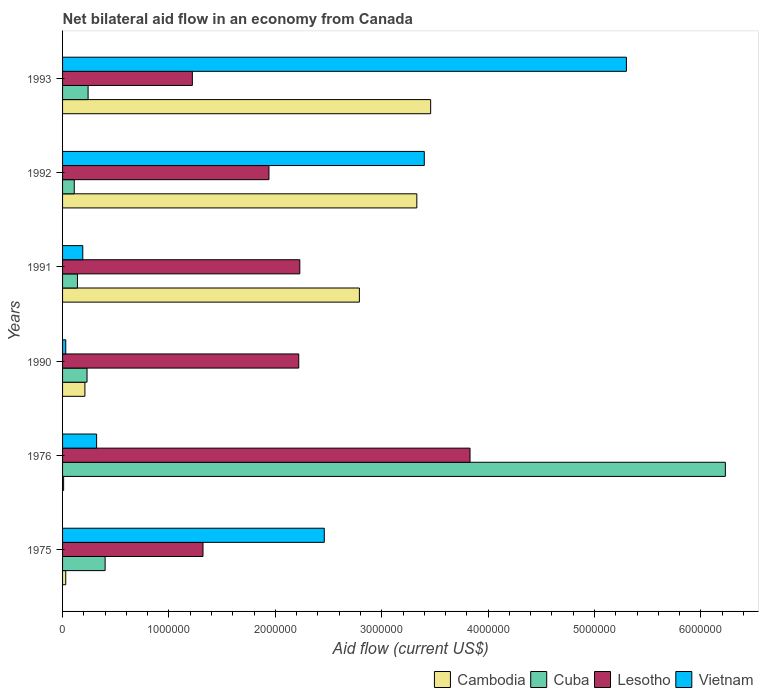How many different coloured bars are there?
Your answer should be very brief. 4. Are the number of bars on each tick of the Y-axis equal?
Provide a short and direct response. Yes. How many bars are there on the 3rd tick from the top?
Provide a succinct answer. 4. What is the label of the 2nd group of bars from the top?
Provide a succinct answer. 1992. What is the net bilateral aid flow in Lesotho in 1993?
Your response must be concise. 1.22e+06. Across all years, what is the maximum net bilateral aid flow in Lesotho?
Make the answer very short. 3.83e+06. What is the total net bilateral aid flow in Cambodia in the graph?
Your response must be concise. 9.83e+06. What is the difference between the net bilateral aid flow in Cuba in 1992 and the net bilateral aid flow in Lesotho in 1976?
Your answer should be very brief. -3.72e+06. What is the average net bilateral aid flow in Cuba per year?
Give a very brief answer. 1.22e+06. In the year 1991, what is the difference between the net bilateral aid flow in Cuba and net bilateral aid flow in Lesotho?
Provide a succinct answer. -2.09e+06. In how many years, is the net bilateral aid flow in Lesotho greater than 5800000 US$?
Make the answer very short. 0. What is the ratio of the net bilateral aid flow in Cuba in 1975 to that in 1976?
Give a very brief answer. 0.06. Is the net bilateral aid flow in Lesotho in 1991 less than that in 1992?
Your answer should be very brief. No. What is the difference between the highest and the second highest net bilateral aid flow in Lesotho?
Offer a terse response. 1.60e+06. What is the difference between the highest and the lowest net bilateral aid flow in Cuba?
Your response must be concise. 6.12e+06. In how many years, is the net bilateral aid flow in Cuba greater than the average net bilateral aid flow in Cuba taken over all years?
Provide a short and direct response. 1. What does the 4th bar from the top in 1975 represents?
Provide a succinct answer. Cambodia. What does the 2nd bar from the bottom in 1991 represents?
Your answer should be compact. Cuba. Is it the case that in every year, the sum of the net bilateral aid flow in Cuba and net bilateral aid flow in Cambodia is greater than the net bilateral aid flow in Lesotho?
Ensure brevity in your answer.  No. Are the values on the major ticks of X-axis written in scientific E-notation?
Your response must be concise. No. Does the graph contain grids?
Offer a very short reply. No. How are the legend labels stacked?
Your answer should be compact. Horizontal. What is the title of the graph?
Ensure brevity in your answer.  Net bilateral aid flow in an economy from Canada. What is the Aid flow (current US$) of Cuba in 1975?
Your answer should be very brief. 4.00e+05. What is the Aid flow (current US$) in Lesotho in 1975?
Offer a terse response. 1.32e+06. What is the Aid flow (current US$) in Vietnam in 1975?
Keep it short and to the point. 2.46e+06. What is the Aid flow (current US$) of Cambodia in 1976?
Your response must be concise. 10000. What is the Aid flow (current US$) in Cuba in 1976?
Offer a very short reply. 6.23e+06. What is the Aid flow (current US$) of Lesotho in 1976?
Give a very brief answer. 3.83e+06. What is the Aid flow (current US$) in Cambodia in 1990?
Keep it short and to the point. 2.10e+05. What is the Aid flow (current US$) in Cuba in 1990?
Your answer should be very brief. 2.30e+05. What is the Aid flow (current US$) of Lesotho in 1990?
Ensure brevity in your answer.  2.22e+06. What is the Aid flow (current US$) of Cambodia in 1991?
Keep it short and to the point. 2.79e+06. What is the Aid flow (current US$) of Lesotho in 1991?
Offer a very short reply. 2.23e+06. What is the Aid flow (current US$) of Vietnam in 1991?
Provide a short and direct response. 1.90e+05. What is the Aid flow (current US$) in Cambodia in 1992?
Your response must be concise. 3.33e+06. What is the Aid flow (current US$) in Lesotho in 1992?
Your answer should be very brief. 1.94e+06. What is the Aid flow (current US$) of Vietnam in 1992?
Give a very brief answer. 3.40e+06. What is the Aid flow (current US$) in Cambodia in 1993?
Provide a short and direct response. 3.46e+06. What is the Aid flow (current US$) in Cuba in 1993?
Give a very brief answer. 2.40e+05. What is the Aid flow (current US$) in Lesotho in 1993?
Provide a succinct answer. 1.22e+06. What is the Aid flow (current US$) of Vietnam in 1993?
Your response must be concise. 5.30e+06. Across all years, what is the maximum Aid flow (current US$) of Cambodia?
Offer a terse response. 3.46e+06. Across all years, what is the maximum Aid flow (current US$) in Cuba?
Give a very brief answer. 6.23e+06. Across all years, what is the maximum Aid flow (current US$) of Lesotho?
Your answer should be very brief. 3.83e+06. Across all years, what is the maximum Aid flow (current US$) in Vietnam?
Ensure brevity in your answer.  5.30e+06. Across all years, what is the minimum Aid flow (current US$) in Cuba?
Provide a succinct answer. 1.10e+05. Across all years, what is the minimum Aid flow (current US$) of Lesotho?
Provide a succinct answer. 1.22e+06. Across all years, what is the minimum Aid flow (current US$) in Vietnam?
Make the answer very short. 3.00e+04. What is the total Aid flow (current US$) of Cambodia in the graph?
Offer a very short reply. 9.83e+06. What is the total Aid flow (current US$) of Cuba in the graph?
Offer a very short reply. 7.35e+06. What is the total Aid flow (current US$) of Lesotho in the graph?
Keep it short and to the point. 1.28e+07. What is the total Aid flow (current US$) in Vietnam in the graph?
Make the answer very short. 1.17e+07. What is the difference between the Aid flow (current US$) in Cuba in 1975 and that in 1976?
Your answer should be compact. -5.83e+06. What is the difference between the Aid flow (current US$) of Lesotho in 1975 and that in 1976?
Your response must be concise. -2.51e+06. What is the difference between the Aid flow (current US$) of Vietnam in 1975 and that in 1976?
Give a very brief answer. 2.14e+06. What is the difference between the Aid flow (current US$) of Cuba in 1975 and that in 1990?
Keep it short and to the point. 1.70e+05. What is the difference between the Aid flow (current US$) of Lesotho in 1975 and that in 1990?
Make the answer very short. -9.00e+05. What is the difference between the Aid flow (current US$) in Vietnam in 1975 and that in 1990?
Make the answer very short. 2.43e+06. What is the difference between the Aid flow (current US$) of Cambodia in 1975 and that in 1991?
Your answer should be compact. -2.76e+06. What is the difference between the Aid flow (current US$) of Cuba in 1975 and that in 1991?
Your answer should be very brief. 2.60e+05. What is the difference between the Aid flow (current US$) of Lesotho in 1975 and that in 1991?
Make the answer very short. -9.10e+05. What is the difference between the Aid flow (current US$) in Vietnam in 1975 and that in 1991?
Your answer should be compact. 2.27e+06. What is the difference between the Aid flow (current US$) in Cambodia in 1975 and that in 1992?
Keep it short and to the point. -3.30e+06. What is the difference between the Aid flow (current US$) of Cuba in 1975 and that in 1992?
Your response must be concise. 2.90e+05. What is the difference between the Aid flow (current US$) in Lesotho in 1975 and that in 1992?
Provide a succinct answer. -6.20e+05. What is the difference between the Aid flow (current US$) in Vietnam in 1975 and that in 1992?
Offer a very short reply. -9.40e+05. What is the difference between the Aid flow (current US$) in Cambodia in 1975 and that in 1993?
Offer a terse response. -3.43e+06. What is the difference between the Aid flow (current US$) in Lesotho in 1975 and that in 1993?
Ensure brevity in your answer.  1.00e+05. What is the difference between the Aid flow (current US$) in Vietnam in 1975 and that in 1993?
Ensure brevity in your answer.  -2.84e+06. What is the difference between the Aid flow (current US$) in Cambodia in 1976 and that in 1990?
Give a very brief answer. -2.00e+05. What is the difference between the Aid flow (current US$) of Cuba in 1976 and that in 1990?
Provide a succinct answer. 6.00e+06. What is the difference between the Aid flow (current US$) in Lesotho in 1976 and that in 1990?
Make the answer very short. 1.61e+06. What is the difference between the Aid flow (current US$) in Cambodia in 1976 and that in 1991?
Make the answer very short. -2.78e+06. What is the difference between the Aid flow (current US$) in Cuba in 1976 and that in 1991?
Your answer should be very brief. 6.09e+06. What is the difference between the Aid flow (current US$) of Lesotho in 1976 and that in 1991?
Offer a very short reply. 1.60e+06. What is the difference between the Aid flow (current US$) in Vietnam in 1976 and that in 1991?
Provide a short and direct response. 1.30e+05. What is the difference between the Aid flow (current US$) in Cambodia in 1976 and that in 1992?
Your answer should be very brief. -3.32e+06. What is the difference between the Aid flow (current US$) of Cuba in 1976 and that in 1992?
Ensure brevity in your answer.  6.12e+06. What is the difference between the Aid flow (current US$) of Lesotho in 1976 and that in 1992?
Provide a short and direct response. 1.89e+06. What is the difference between the Aid flow (current US$) in Vietnam in 1976 and that in 1992?
Offer a very short reply. -3.08e+06. What is the difference between the Aid flow (current US$) in Cambodia in 1976 and that in 1993?
Give a very brief answer. -3.45e+06. What is the difference between the Aid flow (current US$) in Cuba in 1976 and that in 1993?
Keep it short and to the point. 5.99e+06. What is the difference between the Aid flow (current US$) of Lesotho in 1976 and that in 1993?
Offer a very short reply. 2.61e+06. What is the difference between the Aid flow (current US$) of Vietnam in 1976 and that in 1993?
Ensure brevity in your answer.  -4.98e+06. What is the difference between the Aid flow (current US$) in Cambodia in 1990 and that in 1991?
Ensure brevity in your answer.  -2.58e+06. What is the difference between the Aid flow (current US$) in Cuba in 1990 and that in 1991?
Make the answer very short. 9.00e+04. What is the difference between the Aid flow (current US$) of Lesotho in 1990 and that in 1991?
Make the answer very short. -10000. What is the difference between the Aid flow (current US$) in Cambodia in 1990 and that in 1992?
Provide a short and direct response. -3.12e+06. What is the difference between the Aid flow (current US$) in Cuba in 1990 and that in 1992?
Ensure brevity in your answer.  1.20e+05. What is the difference between the Aid flow (current US$) of Lesotho in 1990 and that in 1992?
Make the answer very short. 2.80e+05. What is the difference between the Aid flow (current US$) in Vietnam in 1990 and that in 1992?
Offer a terse response. -3.37e+06. What is the difference between the Aid flow (current US$) in Cambodia in 1990 and that in 1993?
Ensure brevity in your answer.  -3.25e+06. What is the difference between the Aid flow (current US$) of Cuba in 1990 and that in 1993?
Provide a succinct answer. -10000. What is the difference between the Aid flow (current US$) in Vietnam in 1990 and that in 1993?
Provide a succinct answer. -5.27e+06. What is the difference between the Aid flow (current US$) in Cambodia in 1991 and that in 1992?
Make the answer very short. -5.40e+05. What is the difference between the Aid flow (current US$) in Cuba in 1991 and that in 1992?
Your answer should be very brief. 3.00e+04. What is the difference between the Aid flow (current US$) of Vietnam in 1991 and that in 1992?
Your answer should be compact. -3.21e+06. What is the difference between the Aid flow (current US$) of Cambodia in 1991 and that in 1993?
Make the answer very short. -6.70e+05. What is the difference between the Aid flow (current US$) in Lesotho in 1991 and that in 1993?
Your answer should be very brief. 1.01e+06. What is the difference between the Aid flow (current US$) in Vietnam in 1991 and that in 1993?
Your answer should be very brief. -5.11e+06. What is the difference between the Aid flow (current US$) in Cambodia in 1992 and that in 1993?
Your response must be concise. -1.30e+05. What is the difference between the Aid flow (current US$) in Cuba in 1992 and that in 1993?
Your answer should be compact. -1.30e+05. What is the difference between the Aid flow (current US$) in Lesotho in 1992 and that in 1993?
Provide a short and direct response. 7.20e+05. What is the difference between the Aid flow (current US$) in Vietnam in 1992 and that in 1993?
Offer a very short reply. -1.90e+06. What is the difference between the Aid flow (current US$) in Cambodia in 1975 and the Aid flow (current US$) in Cuba in 1976?
Ensure brevity in your answer.  -6.20e+06. What is the difference between the Aid flow (current US$) in Cambodia in 1975 and the Aid flow (current US$) in Lesotho in 1976?
Offer a terse response. -3.80e+06. What is the difference between the Aid flow (current US$) in Cambodia in 1975 and the Aid flow (current US$) in Vietnam in 1976?
Your response must be concise. -2.90e+05. What is the difference between the Aid flow (current US$) of Cuba in 1975 and the Aid flow (current US$) of Lesotho in 1976?
Provide a succinct answer. -3.43e+06. What is the difference between the Aid flow (current US$) in Cambodia in 1975 and the Aid flow (current US$) in Lesotho in 1990?
Your response must be concise. -2.19e+06. What is the difference between the Aid flow (current US$) in Cambodia in 1975 and the Aid flow (current US$) in Vietnam in 1990?
Provide a short and direct response. 0. What is the difference between the Aid flow (current US$) in Cuba in 1975 and the Aid flow (current US$) in Lesotho in 1990?
Your answer should be compact. -1.82e+06. What is the difference between the Aid flow (current US$) of Cuba in 1975 and the Aid flow (current US$) of Vietnam in 1990?
Make the answer very short. 3.70e+05. What is the difference between the Aid flow (current US$) of Lesotho in 1975 and the Aid flow (current US$) of Vietnam in 1990?
Ensure brevity in your answer.  1.29e+06. What is the difference between the Aid flow (current US$) in Cambodia in 1975 and the Aid flow (current US$) in Lesotho in 1991?
Provide a succinct answer. -2.20e+06. What is the difference between the Aid flow (current US$) in Cuba in 1975 and the Aid flow (current US$) in Lesotho in 1991?
Keep it short and to the point. -1.83e+06. What is the difference between the Aid flow (current US$) of Cuba in 1975 and the Aid flow (current US$) of Vietnam in 1991?
Provide a short and direct response. 2.10e+05. What is the difference between the Aid flow (current US$) in Lesotho in 1975 and the Aid flow (current US$) in Vietnam in 1991?
Give a very brief answer. 1.13e+06. What is the difference between the Aid flow (current US$) of Cambodia in 1975 and the Aid flow (current US$) of Lesotho in 1992?
Keep it short and to the point. -1.91e+06. What is the difference between the Aid flow (current US$) of Cambodia in 1975 and the Aid flow (current US$) of Vietnam in 1992?
Offer a terse response. -3.37e+06. What is the difference between the Aid flow (current US$) in Cuba in 1975 and the Aid flow (current US$) in Lesotho in 1992?
Ensure brevity in your answer.  -1.54e+06. What is the difference between the Aid flow (current US$) in Cuba in 1975 and the Aid flow (current US$) in Vietnam in 1992?
Your response must be concise. -3.00e+06. What is the difference between the Aid flow (current US$) of Lesotho in 1975 and the Aid flow (current US$) of Vietnam in 1992?
Ensure brevity in your answer.  -2.08e+06. What is the difference between the Aid flow (current US$) of Cambodia in 1975 and the Aid flow (current US$) of Lesotho in 1993?
Your response must be concise. -1.19e+06. What is the difference between the Aid flow (current US$) of Cambodia in 1975 and the Aid flow (current US$) of Vietnam in 1993?
Provide a succinct answer. -5.27e+06. What is the difference between the Aid flow (current US$) in Cuba in 1975 and the Aid flow (current US$) in Lesotho in 1993?
Ensure brevity in your answer.  -8.20e+05. What is the difference between the Aid flow (current US$) in Cuba in 1975 and the Aid flow (current US$) in Vietnam in 1993?
Make the answer very short. -4.90e+06. What is the difference between the Aid flow (current US$) of Lesotho in 1975 and the Aid flow (current US$) of Vietnam in 1993?
Offer a terse response. -3.98e+06. What is the difference between the Aid flow (current US$) in Cambodia in 1976 and the Aid flow (current US$) in Cuba in 1990?
Offer a very short reply. -2.20e+05. What is the difference between the Aid flow (current US$) of Cambodia in 1976 and the Aid flow (current US$) of Lesotho in 1990?
Your response must be concise. -2.21e+06. What is the difference between the Aid flow (current US$) in Cuba in 1976 and the Aid flow (current US$) in Lesotho in 1990?
Your answer should be compact. 4.01e+06. What is the difference between the Aid flow (current US$) in Cuba in 1976 and the Aid flow (current US$) in Vietnam in 1990?
Your answer should be compact. 6.20e+06. What is the difference between the Aid flow (current US$) in Lesotho in 1976 and the Aid flow (current US$) in Vietnam in 1990?
Provide a short and direct response. 3.80e+06. What is the difference between the Aid flow (current US$) in Cambodia in 1976 and the Aid flow (current US$) in Lesotho in 1991?
Keep it short and to the point. -2.22e+06. What is the difference between the Aid flow (current US$) of Cambodia in 1976 and the Aid flow (current US$) of Vietnam in 1991?
Ensure brevity in your answer.  -1.80e+05. What is the difference between the Aid flow (current US$) of Cuba in 1976 and the Aid flow (current US$) of Lesotho in 1991?
Offer a very short reply. 4.00e+06. What is the difference between the Aid flow (current US$) of Cuba in 1976 and the Aid flow (current US$) of Vietnam in 1991?
Provide a short and direct response. 6.04e+06. What is the difference between the Aid flow (current US$) of Lesotho in 1976 and the Aid flow (current US$) of Vietnam in 1991?
Make the answer very short. 3.64e+06. What is the difference between the Aid flow (current US$) in Cambodia in 1976 and the Aid flow (current US$) in Cuba in 1992?
Make the answer very short. -1.00e+05. What is the difference between the Aid flow (current US$) of Cambodia in 1976 and the Aid flow (current US$) of Lesotho in 1992?
Give a very brief answer. -1.93e+06. What is the difference between the Aid flow (current US$) of Cambodia in 1976 and the Aid flow (current US$) of Vietnam in 1992?
Make the answer very short. -3.39e+06. What is the difference between the Aid flow (current US$) of Cuba in 1976 and the Aid flow (current US$) of Lesotho in 1992?
Give a very brief answer. 4.29e+06. What is the difference between the Aid flow (current US$) in Cuba in 1976 and the Aid flow (current US$) in Vietnam in 1992?
Offer a very short reply. 2.83e+06. What is the difference between the Aid flow (current US$) in Lesotho in 1976 and the Aid flow (current US$) in Vietnam in 1992?
Your response must be concise. 4.30e+05. What is the difference between the Aid flow (current US$) of Cambodia in 1976 and the Aid flow (current US$) of Lesotho in 1993?
Offer a terse response. -1.21e+06. What is the difference between the Aid flow (current US$) of Cambodia in 1976 and the Aid flow (current US$) of Vietnam in 1993?
Your response must be concise. -5.29e+06. What is the difference between the Aid flow (current US$) in Cuba in 1976 and the Aid flow (current US$) in Lesotho in 1993?
Give a very brief answer. 5.01e+06. What is the difference between the Aid flow (current US$) in Cuba in 1976 and the Aid flow (current US$) in Vietnam in 1993?
Offer a terse response. 9.30e+05. What is the difference between the Aid flow (current US$) in Lesotho in 1976 and the Aid flow (current US$) in Vietnam in 1993?
Give a very brief answer. -1.47e+06. What is the difference between the Aid flow (current US$) of Cambodia in 1990 and the Aid flow (current US$) of Cuba in 1991?
Make the answer very short. 7.00e+04. What is the difference between the Aid flow (current US$) of Cambodia in 1990 and the Aid flow (current US$) of Lesotho in 1991?
Keep it short and to the point. -2.02e+06. What is the difference between the Aid flow (current US$) of Cambodia in 1990 and the Aid flow (current US$) of Vietnam in 1991?
Your response must be concise. 2.00e+04. What is the difference between the Aid flow (current US$) of Cuba in 1990 and the Aid flow (current US$) of Lesotho in 1991?
Offer a terse response. -2.00e+06. What is the difference between the Aid flow (current US$) in Lesotho in 1990 and the Aid flow (current US$) in Vietnam in 1991?
Keep it short and to the point. 2.03e+06. What is the difference between the Aid flow (current US$) of Cambodia in 1990 and the Aid flow (current US$) of Lesotho in 1992?
Offer a very short reply. -1.73e+06. What is the difference between the Aid flow (current US$) of Cambodia in 1990 and the Aid flow (current US$) of Vietnam in 1992?
Offer a terse response. -3.19e+06. What is the difference between the Aid flow (current US$) in Cuba in 1990 and the Aid flow (current US$) in Lesotho in 1992?
Ensure brevity in your answer.  -1.71e+06. What is the difference between the Aid flow (current US$) in Cuba in 1990 and the Aid flow (current US$) in Vietnam in 1992?
Ensure brevity in your answer.  -3.17e+06. What is the difference between the Aid flow (current US$) of Lesotho in 1990 and the Aid flow (current US$) of Vietnam in 1992?
Ensure brevity in your answer.  -1.18e+06. What is the difference between the Aid flow (current US$) in Cambodia in 1990 and the Aid flow (current US$) in Lesotho in 1993?
Keep it short and to the point. -1.01e+06. What is the difference between the Aid flow (current US$) of Cambodia in 1990 and the Aid flow (current US$) of Vietnam in 1993?
Your response must be concise. -5.09e+06. What is the difference between the Aid flow (current US$) in Cuba in 1990 and the Aid flow (current US$) in Lesotho in 1993?
Provide a succinct answer. -9.90e+05. What is the difference between the Aid flow (current US$) of Cuba in 1990 and the Aid flow (current US$) of Vietnam in 1993?
Offer a very short reply. -5.07e+06. What is the difference between the Aid flow (current US$) in Lesotho in 1990 and the Aid flow (current US$) in Vietnam in 1993?
Provide a short and direct response. -3.08e+06. What is the difference between the Aid flow (current US$) in Cambodia in 1991 and the Aid flow (current US$) in Cuba in 1992?
Give a very brief answer. 2.68e+06. What is the difference between the Aid flow (current US$) of Cambodia in 1991 and the Aid flow (current US$) of Lesotho in 1992?
Ensure brevity in your answer.  8.50e+05. What is the difference between the Aid flow (current US$) of Cambodia in 1991 and the Aid flow (current US$) of Vietnam in 1992?
Make the answer very short. -6.10e+05. What is the difference between the Aid flow (current US$) of Cuba in 1991 and the Aid flow (current US$) of Lesotho in 1992?
Keep it short and to the point. -1.80e+06. What is the difference between the Aid flow (current US$) of Cuba in 1991 and the Aid flow (current US$) of Vietnam in 1992?
Keep it short and to the point. -3.26e+06. What is the difference between the Aid flow (current US$) in Lesotho in 1991 and the Aid flow (current US$) in Vietnam in 1992?
Make the answer very short. -1.17e+06. What is the difference between the Aid flow (current US$) of Cambodia in 1991 and the Aid flow (current US$) of Cuba in 1993?
Offer a very short reply. 2.55e+06. What is the difference between the Aid flow (current US$) of Cambodia in 1991 and the Aid flow (current US$) of Lesotho in 1993?
Your response must be concise. 1.57e+06. What is the difference between the Aid flow (current US$) in Cambodia in 1991 and the Aid flow (current US$) in Vietnam in 1993?
Offer a very short reply. -2.51e+06. What is the difference between the Aid flow (current US$) of Cuba in 1991 and the Aid flow (current US$) of Lesotho in 1993?
Your answer should be compact. -1.08e+06. What is the difference between the Aid flow (current US$) of Cuba in 1991 and the Aid flow (current US$) of Vietnam in 1993?
Provide a succinct answer. -5.16e+06. What is the difference between the Aid flow (current US$) of Lesotho in 1991 and the Aid flow (current US$) of Vietnam in 1993?
Provide a succinct answer. -3.07e+06. What is the difference between the Aid flow (current US$) of Cambodia in 1992 and the Aid flow (current US$) of Cuba in 1993?
Keep it short and to the point. 3.09e+06. What is the difference between the Aid flow (current US$) in Cambodia in 1992 and the Aid flow (current US$) in Lesotho in 1993?
Provide a succinct answer. 2.11e+06. What is the difference between the Aid flow (current US$) in Cambodia in 1992 and the Aid flow (current US$) in Vietnam in 1993?
Ensure brevity in your answer.  -1.97e+06. What is the difference between the Aid flow (current US$) of Cuba in 1992 and the Aid flow (current US$) of Lesotho in 1993?
Provide a short and direct response. -1.11e+06. What is the difference between the Aid flow (current US$) of Cuba in 1992 and the Aid flow (current US$) of Vietnam in 1993?
Provide a succinct answer. -5.19e+06. What is the difference between the Aid flow (current US$) of Lesotho in 1992 and the Aid flow (current US$) of Vietnam in 1993?
Make the answer very short. -3.36e+06. What is the average Aid flow (current US$) of Cambodia per year?
Keep it short and to the point. 1.64e+06. What is the average Aid flow (current US$) of Cuba per year?
Provide a succinct answer. 1.22e+06. What is the average Aid flow (current US$) in Lesotho per year?
Make the answer very short. 2.13e+06. What is the average Aid flow (current US$) in Vietnam per year?
Keep it short and to the point. 1.95e+06. In the year 1975, what is the difference between the Aid flow (current US$) in Cambodia and Aid flow (current US$) in Cuba?
Provide a succinct answer. -3.70e+05. In the year 1975, what is the difference between the Aid flow (current US$) in Cambodia and Aid flow (current US$) in Lesotho?
Make the answer very short. -1.29e+06. In the year 1975, what is the difference between the Aid flow (current US$) of Cambodia and Aid flow (current US$) of Vietnam?
Your response must be concise. -2.43e+06. In the year 1975, what is the difference between the Aid flow (current US$) in Cuba and Aid flow (current US$) in Lesotho?
Make the answer very short. -9.20e+05. In the year 1975, what is the difference between the Aid flow (current US$) in Cuba and Aid flow (current US$) in Vietnam?
Ensure brevity in your answer.  -2.06e+06. In the year 1975, what is the difference between the Aid flow (current US$) in Lesotho and Aid flow (current US$) in Vietnam?
Keep it short and to the point. -1.14e+06. In the year 1976, what is the difference between the Aid flow (current US$) in Cambodia and Aid flow (current US$) in Cuba?
Keep it short and to the point. -6.22e+06. In the year 1976, what is the difference between the Aid flow (current US$) of Cambodia and Aid flow (current US$) of Lesotho?
Offer a terse response. -3.82e+06. In the year 1976, what is the difference between the Aid flow (current US$) of Cambodia and Aid flow (current US$) of Vietnam?
Offer a terse response. -3.10e+05. In the year 1976, what is the difference between the Aid flow (current US$) in Cuba and Aid flow (current US$) in Lesotho?
Offer a terse response. 2.40e+06. In the year 1976, what is the difference between the Aid flow (current US$) in Cuba and Aid flow (current US$) in Vietnam?
Your response must be concise. 5.91e+06. In the year 1976, what is the difference between the Aid flow (current US$) of Lesotho and Aid flow (current US$) of Vietnam?
Your answer should be very brief. 3.51e+06. In the year 1990, what is the difference between the Aid flow (current US$) in Cambodia and Aid flow (current US$) in Cuba?
Your answer should be compact. -2.00e+04. In the year 1990, what is the difference between the Aid flow (current US$) in Cambodia and Aid flow (current US$) in Lesotho?
Offer a very short reply. -2.01e+06. In the year 1990, what is the difference between the Aid flow (current US$) in Cuba and Aid flow (current US$) in Lesotho?
Your answer should be compact. -1.99e+06. In the year 1990, what is the difference between the Aid flow (current US$) of Cuba and Aid flow (current US$) of Vietnam?
Keep it short and to the point. 2.00e+05. In the year 1990, what is the difference between the Aid flow (current US$) in Lesotho and Aid flow (current US$) in Vietnam?
Your answer should be very brief. 2.19e+06. In the year 1991, what is the difference between the Aid flow (current US$) in Cambodia and Aid flow (current US$) in Cuba?
Your answer should be compact. 2.65e+06. In the year 1991, what is the difference between the Aid flow (current US$) of Cambodia and Aid flow (current US$) of Lesotho?
Your answer should be compact. 5.60e+05. In the year 1991, what is the difference between the Aid flow (current US$) in Cambodia and Aid flow (current US$) in Vietnam?
Offer a very short reply. 2.60e+06. In the year 1991, what is the difference between the Aid flow (current US$) in Cuba and Aid flow (current US$) in Lesotho?
Offer a terse response. -2.09e+06. In the year 1991, what is the difference between the Aid flow (current US$) of Cuba and Aid flow (current US$) of Vietnam?
Keep it short and to the point. -5.00e+04. In the year 1991, what is the difference between the Aid flow (current US$) of Lesotho and Aid flow (current US$) of Vietnam?
Your answer should be compact. 2.04e+06. In the year 1992, what is the difference between the Aid flow (current US$) of Cambodia and Aid flow (current US$) of Cuba?
Your response must be concise. 3.22e+06. In the year 1992, what is the difference between the Aid flow (current US$) of Cambodia and Aid flow (current US$) of Lesotho?
Ensure brevity in your answer.  1.39e+06. In the year 1992, what is the difference between the Aid flow (current US$) of Cambodia and Aid flow (current US$) of Vietnam?
Keep it short and to the point. -7.00e+04. In the year 1992, what is the difference between the Aid flow (current US$) of Cuba and Aid flow (current US$) of Lesotho?
Offer a terse response. -1.83e+06. In the year 1992, what is the difference between the Aid flow (current US$) in Cuba and Aid flow (current US$) in Vietnam?
Provide a succinct answer. -3.29e+06. In the year 1992, what is the difference between the Aid flow (current US$) of Lesotho and Aid flow (current US$) of Vietnam?
Give a very brief answer. -1.46e+06. In the year 1993, what is the difference between the Aid flow (current US$) in Cambodia and Aid flow (current US$) in Cuba?
Ensure brevity in your answer.  3.22e+06. In the year 1993, what is the difference between the Aid flow (current US$) of Cambodia and Aid flow (current US$) of Lesotho?
Keep it short and to the point. 2.24e+06. In the year 1993, what is the difference between the Aid flow (current US$) of Cambodia and Aid flow (current US$) of Vietnam?
Ensure brevity in your answer.  -1.84e+06. In the year 1993, what is the difference between the Aid flow (current US$) in Cuba and Aid flow (current US$) in Lesotho?
Your answer should be very brief. -9.80e+05. In the year 1993, what is the difference between the Aid flow (current US$) in Cuba and Aid flow (current US$) in Vietnam?
Make the answer very short. -5.06e+06. In the year 1993, what is the difference between the Aid flow (current US$) of Lesotho and Aid flow (current US$) of Vietnam?
Offer a very short reply. -4.08e+06. What is the ratio of the Aid flow (current US$) of Cuba in 1975 to that in 1976?
Your response must be concise. 0.06. What is the ratio of the Aid flow (current US$) in Lesotho in 1975 to that in 1976?
Your response must be concise. 0.34. What is the ratio of the Aid flow (current US$) of Vietnam in 1975 to that in 1976?
Keep it short and to the point. 7.69. What is the ratio of the Aid flow (current US$) in Cambodia in 1975 to that in 1990?
Your response must be concise. 0.14. What is the ratio of the Aid flow (current US$) of Cuba in 1975 to that in 1990?
Provide a succinct answer. 1.74. What is the ratio of the Aid flow (current US$) of Lesotho in 1975 to that in 1990?
Give a very brief answer. 0.59. What is the ratio of the Aid flow (current US$) of Cambodia in 1975 to that in 1991?
Keep it short and to the point. 0.01. What is the ratio of the Aid flow (current US$) of Cuba in 1975 to that in 1991?
Your response must be concise. 2.86. What is the ratio of the Aid flow (current US$) in Lesotho in 1975 to that in 1991?
Provide a succinct answer. 0.59. What is the ratio of the Aid flow (current US$) of Vietnam in 1975 to that in 1991?
Offer a terse response. 12.95. What is the ratio of the Aid flow (current US$) of Cambodia in 1975 to that in 1992?
Provide a short and direct response. 0.01. What is the ratio of the Aid flow (current US$) in Cuba in 1975 to that in 1992?
Your response must be concise. 3.64. What is the ratio of the Aid flow (current US$) of Lesotho in 1975 to that in 1992?
Offer a very short reply. 0.68. What is the ratio of the Aid flow (current US$) of Vietnam in 1975 to that in 1992?
Your response must be concise. 0.72. What is the ratio of the Aid flow (current US$) in Cambodia in 1975 to that in 1993?
Your answer should be very brief. 0.01. What is the ratio of the Aid flow (current US$) in Lesotho in 1975 to that in 1993?
Offer a very short reply. 1.08. What is the ratio of the Aid flow (current US$) of Vietnam in 1975 to that in 1993?
Provide a short and direct response. 0.46. What is the ratio of the Aid flow (current US$) of Cambodia in 1976 to that in 1990?
Make the answer very short. 0.05. What is the ratio of the Aid flow (current US$) in Cuba in 1976 to that in 1990?
Provide a succinct answer. 27.09. What is the ratio of the Aid flow (current US$) of Lesotho in 1976 to that in 1990?
Give a very brief answer. 1.73. What is the ratio of the Aid flow (current US$) of Vietnam in 1976 to that in 1990?
Give a very brief answer. 10.67. What is the ratio of the Aid flow (current US$) in Cambodia in 1976 to that in 1991?
Provide a short and direct response. 0. What is the ratio of the Aid flow (current US$) of Cuba in 1976 to that in 1991?
Ensure brevity in your answer.  44.5. What is the ratio of the Aid flow (current US$) in Lesotho in 1976 to that in 1991?
Offer a terse response. 1.72. What is the ratio of the Aid flow (current US$) of Vietnam in 1976 to that in 1991?
Your answer should be compact. 1.68. What is the ratio of the Aid flow (current US$) of Cambodia in 1976 to that in 1992?
Your answer should be very brief. 0. What is the ratio of the Aid flow (current US$) of Cuba in 1976 to that in 1992?
Make the answer very short. 56.64. What is the ratio of the Aid flow (current US$) in Lesotho in 1976 to that in 1992?
Ensure brevity in your answer.  1.97. What is the ratio of the Aid flow (current US$) of Vietnam in 1976 to that in 1992?
Your response must be concise. 0.09. What is the ratio of the Aid flow (current US$) in Cambodia in 1976 to that in 1993?
Ensure brevity in your answer.  0. What is the ratio of the Aid flow (current US$) in Cuba in 1976 to that in 1993?
Offer a terse response. 25.96. What is the ratio of the Aid flow (current US$) in Lesotho in 1976 to that in 1993?
Give a very brief answer. 3.14. What is the ratio of the Aid flow (current US$) of Vietnam in 1976 to that in 1993?
Offer a very short reply. 0.06. What is the ratio of the Aid flow (current US$) in Cambodia in 1990 to that in 1991?
Provide a succinct answer. 0.08. What is the ratio of the Aid flow (current US$) in Cuba in 1990 to that in 1991?
Provide a succinct answer. 1.64. What is the ratio of the Aid flow (current US$) of Vietnam in 1990 to that in 1991?
Keep it short and to the point. 0.16. What is the ratio of the Aid flow (current US$) of Cambodia in 1990 to that in 1992?
Your answer should be compact. 0.06. What is the ratio of the Aid flow (current US$) of Cuba in 1990 to that in 1992?
Offer a terse response. 2.09. What is the ratio of the Aid flow (current US$) in Lesotho in 1990 to that in 1992?
Give a very brief answer. 1.14. What is the ratio of the Aid flow (current US$) of Vietnam in 1990 to that in 1992?
Ensure brevity in your answer.  0.01. What is the ratio of the Aid flow (current US$) of Cambodia in 1990 to that in 1993?
Give a very brief answer. 0.06. What is the ratio of the Aid flow (current US$) in Cuba in 1990 to that in 1993?
Your answer should be very brief. 0.96. What is the ratio of the Aid flow (current US$) in Lesotho in 1990 to that in 1993?
Offer a very short reply. 1.82. What is the ratio of the Aid flow (current US$) in Vietnam in 1990 to that in 1993?
Make the answer very short. 0.01. What is the ratio of the Aid flow (current US$) of Cambodia in 1991 to that in 1992?
Your answer should be compact. 0.84. What is the ratio of the Aid flow (current US$) of Cuba in 1991 to that in 1992?
Your answer should be compact. 1.27. What is the ratio of the Aid flow (current US$) of Lesotho in 1991 to that in 1992?
Your response must be concise. 1.15. What is the ratio of the Aid flow (current US$) in Vietnam in 1991 to that in 1992?
Keep it short and to the point. 0.06. What is the ratio of the Aid flow (current US$) in Cambodia in 1991 to that in 1993?
Offer a terse response. 0.81. What is the ratio of the Aid flow (current US$) in Cuba in 1991 to that in 1993?
Your answer should be compact. 0.58. What is the ratio of the Aid flow (current US$) of Lesotho in 1991 to that in 1993?
Provide a short and direct response. 1.83. What is the ratio of the Aid flow (current US$) of Vietnam in 1991 to that in 1993?
Ensure brevity in your answer.  0.04. What is the ratio of the Aid flow (current US$) in Cambodia in 1992 to that in 1993?
Offer a very short reply. 0.96. What is the ratio of the Aid flow (current US$) in Cuba in 1992 to that in 1993?
Ensure brevity in your answer.  0.46. What is the ratio of the Aid flow (current US$) in Lesotho in 1992 to that in 1993?
Your answer should be compact. 1.59. What is the ratio of the Aid flow (current US$) of Vietnam in 1992 to that in 1993?
Your response must be concise. 0.64. What is the difference between the highest and the second highest Aid flow (current US$) in Cuba?
Give a very brief answer. 5.83e+06. What is the difference between the highest and the second highest Aid flow (current US$) in Lesotho?
Ensure brevity in your answer.  1.60e+06. What is the difference between the highest and the second highest Aid flow (current US$) in Vietnam?
Keep it short and to the point. 1.90e+06. What is the difference between the highest and the lowest Aid flow (current US$) of Cambodia?
Offer a very short reply. 3.45e+06. What is the difference between the highest and the lowest Aid flow (current US$) of Cuba?
Provide a succinct answer. 6.12e+06. What is the difference between the highest and the lowest Aid flow (current US$) of Lesotho?
Give a very brief answer. 2.61e+06. What is the difference between the highest and the lowest Aid flow (current US$) in Vietnam?
Your response must be concise. 5.27e+06. 